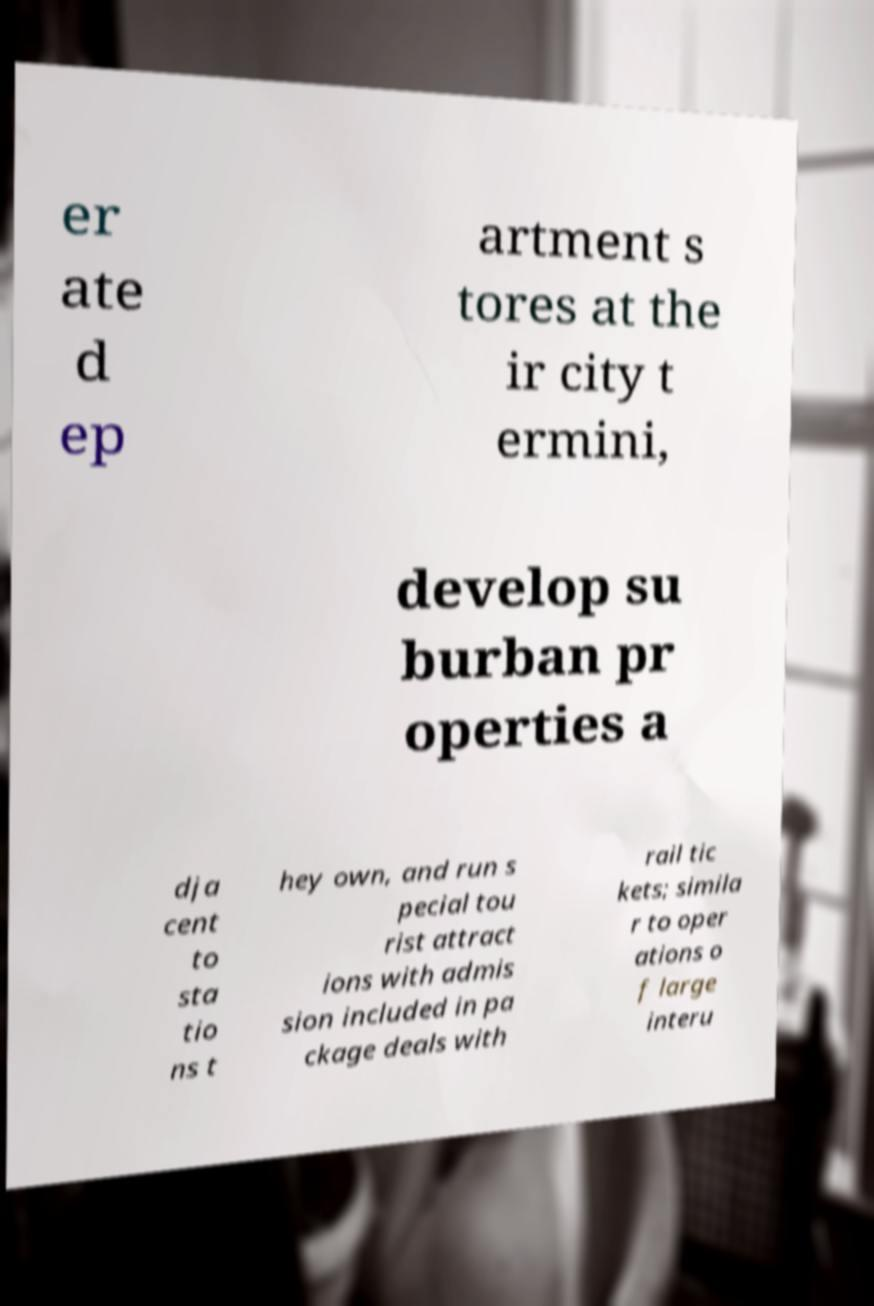Please identify and transcribe the text found in this image. er ate d ep artment s tores at the ir city t ermini, develop su burban pr operties a dja cent to sta tio ns t hey own, and run s pecial tou rist attract ions with admis sion included in pa ckage deals with rail tic kets; simila r to oper ations o f large interu 